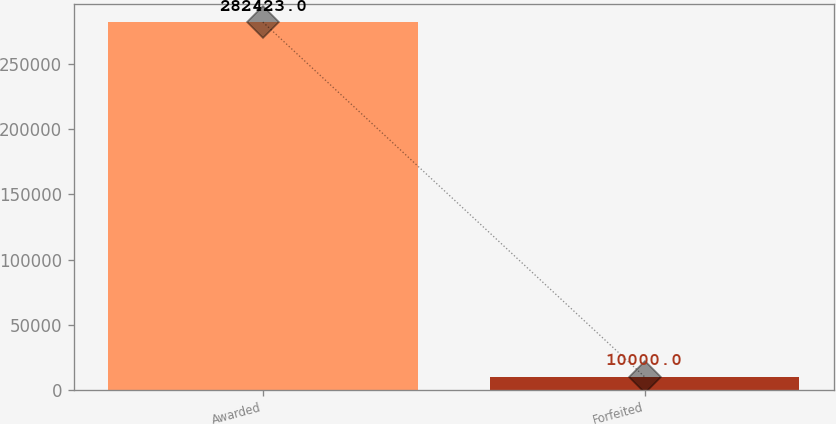Convert chart to OTSL. <chart><loc_0><loc_0><loc_500><loc_500><bar_chart><fcel>Awarded<fcel>Forfeited<nl><fcel>282423<fcel>10000<nl></chart> 